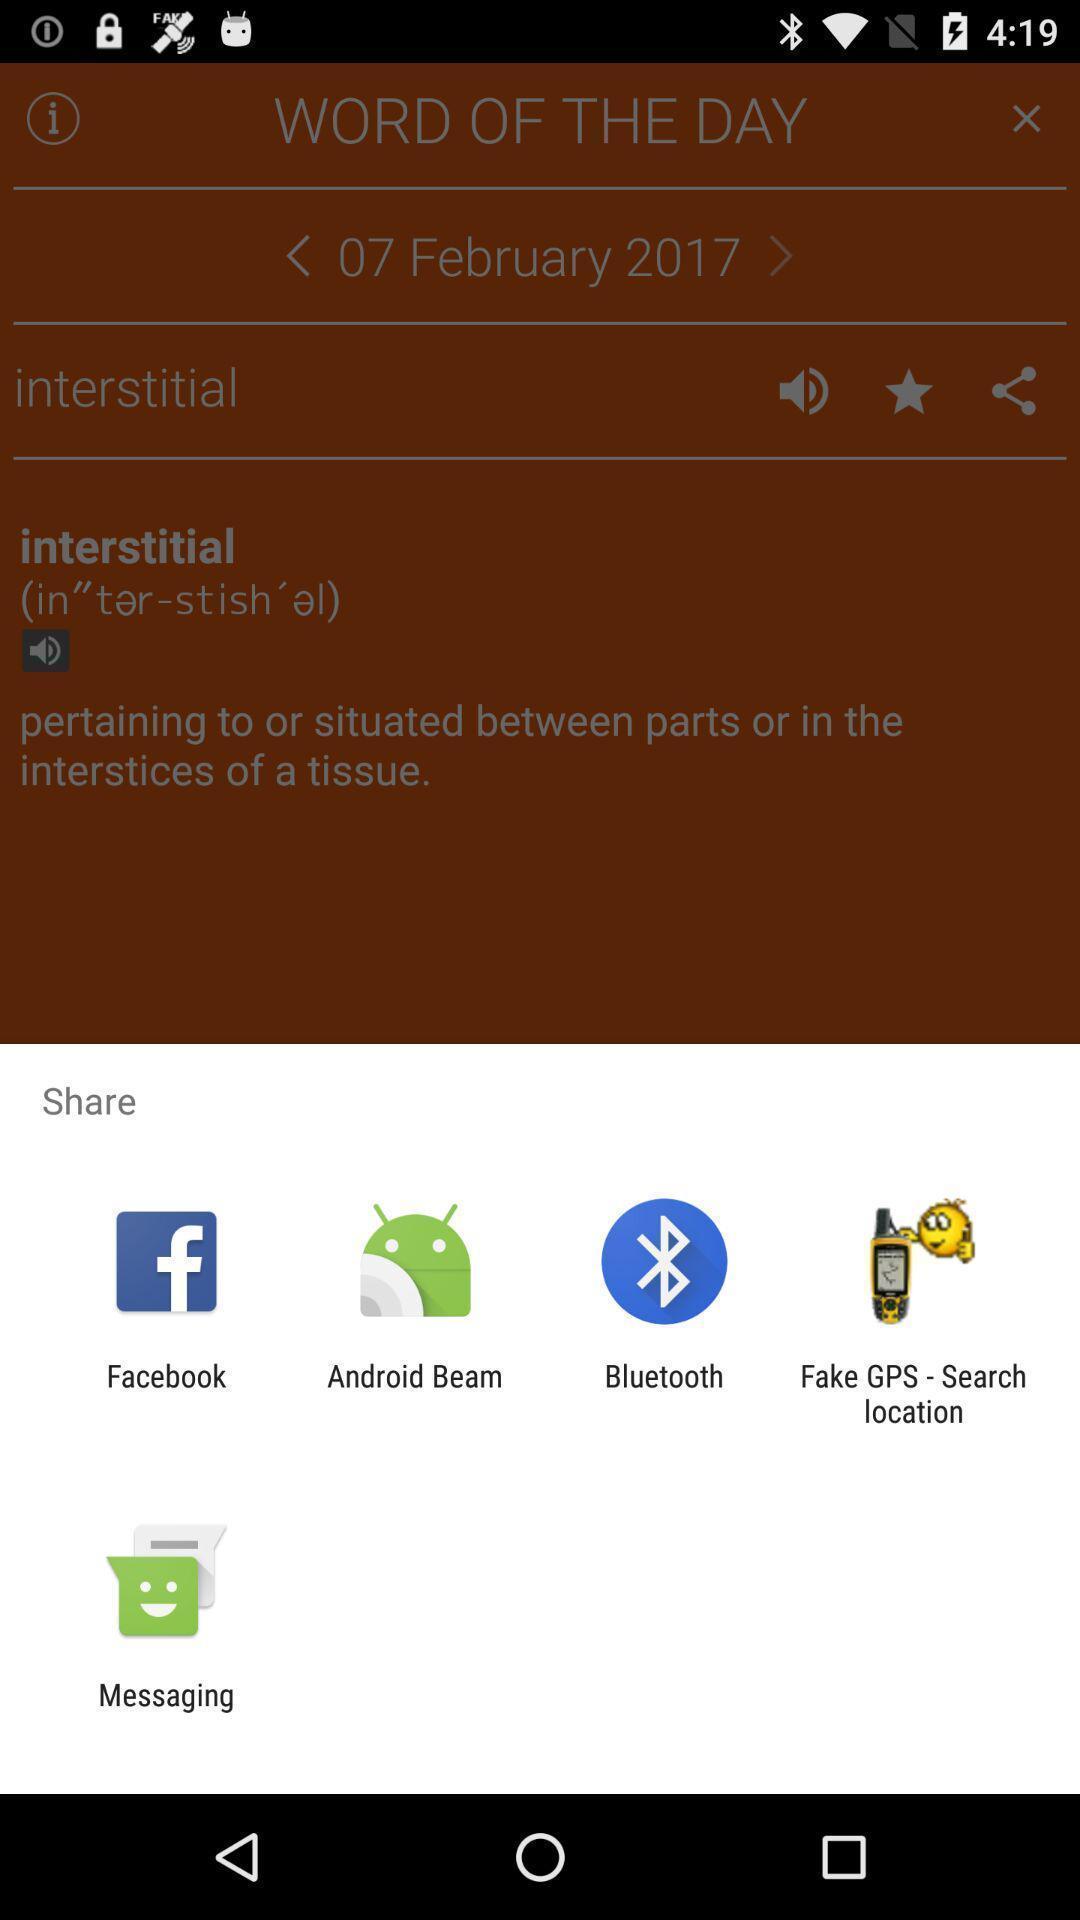Give me a summary of this screen capture. Pop-up widget showing various data sharing apps. 